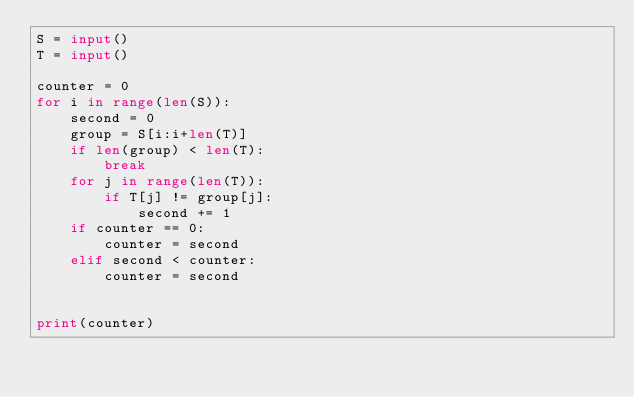Convert code to text. <code><loc_0><loc_0><loc_500><loc_500><_Python_>S = input()
T = input()

counter = 0
for i in range(len(S)):
    second = 0
    group = S[i:i+len(T)]
    if len(group) < len(T):
        break
    for j in range(len(T)):
        if T[j] != group[j]:
            second += 1
    if counter == 0:
        counter = second
    elif second < counter:
        counter = second


print(counter)</code> 